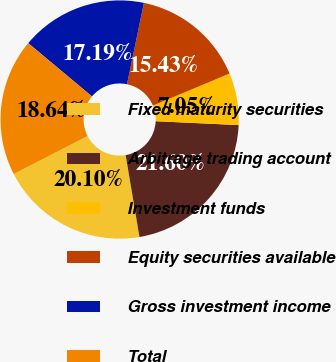Convert chart. <chart><loc_0><loc_0><loc_500><loc_500><pie_chart><fcel>Fixed maturity securities<fcel>Arbitrage trading account<fcel>Investment funds<fcel>Equity securities available<fcel>Gross investment income<fcel>Total<nl><fcel>20.1%<fcel>21.6%<fcel>7.05%<fcel>15.43%<fcel>17.19%<fcel>18.64%<nl></chart> 